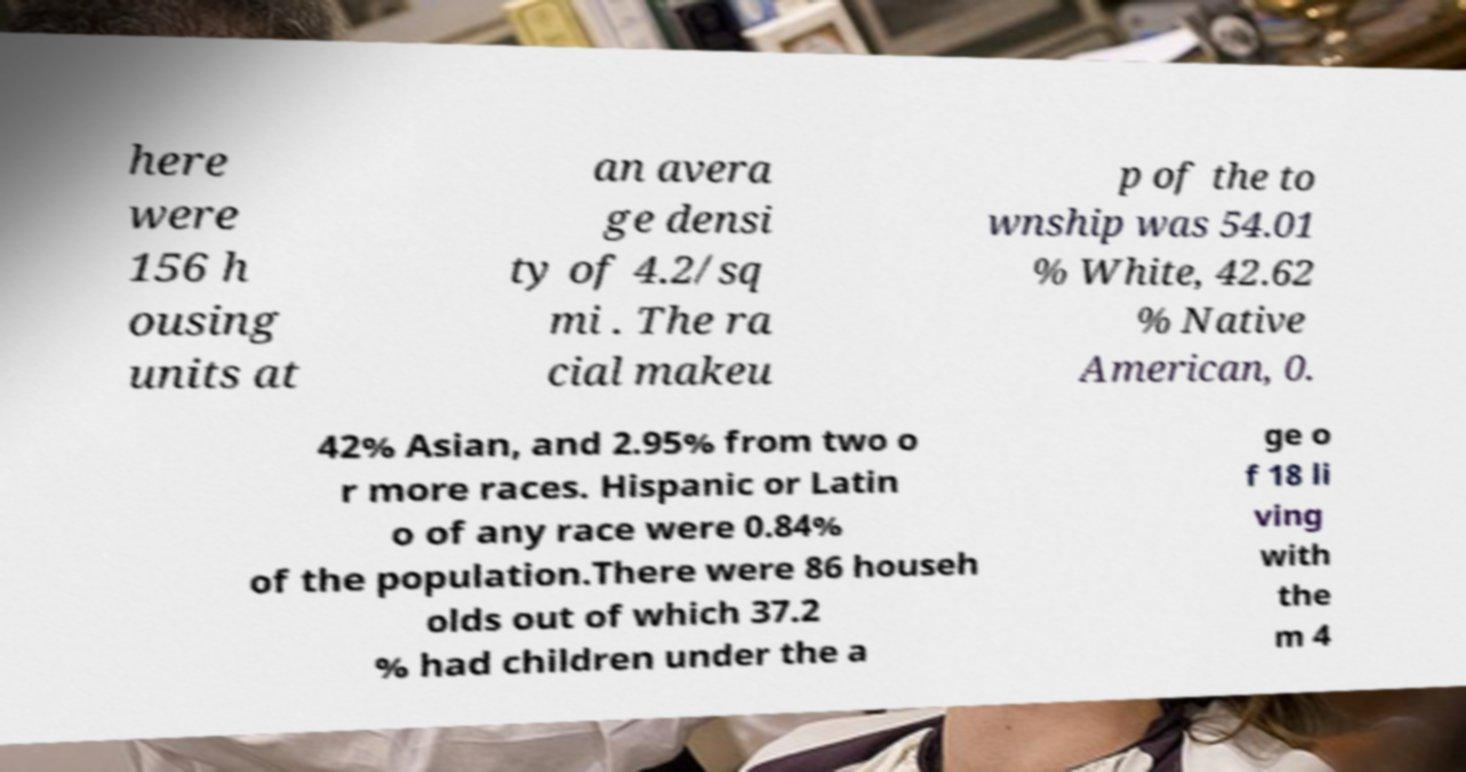Please read and relay the text visible in this image. What does it say? here were 156 h ousing units at an avera ge densi ty of 4.2/sq mi . The ra cial makeu p of the to wnship was 54.01 % White, 42.62 % Native American, 0. 42% Asian, and 2.95% from two o r more races. Hispanic or Latin o of any race were 0.84% of the population.There were 86 househ olds out of which 37.2 % had children under the a ge o f 18 li ving with the m 4 